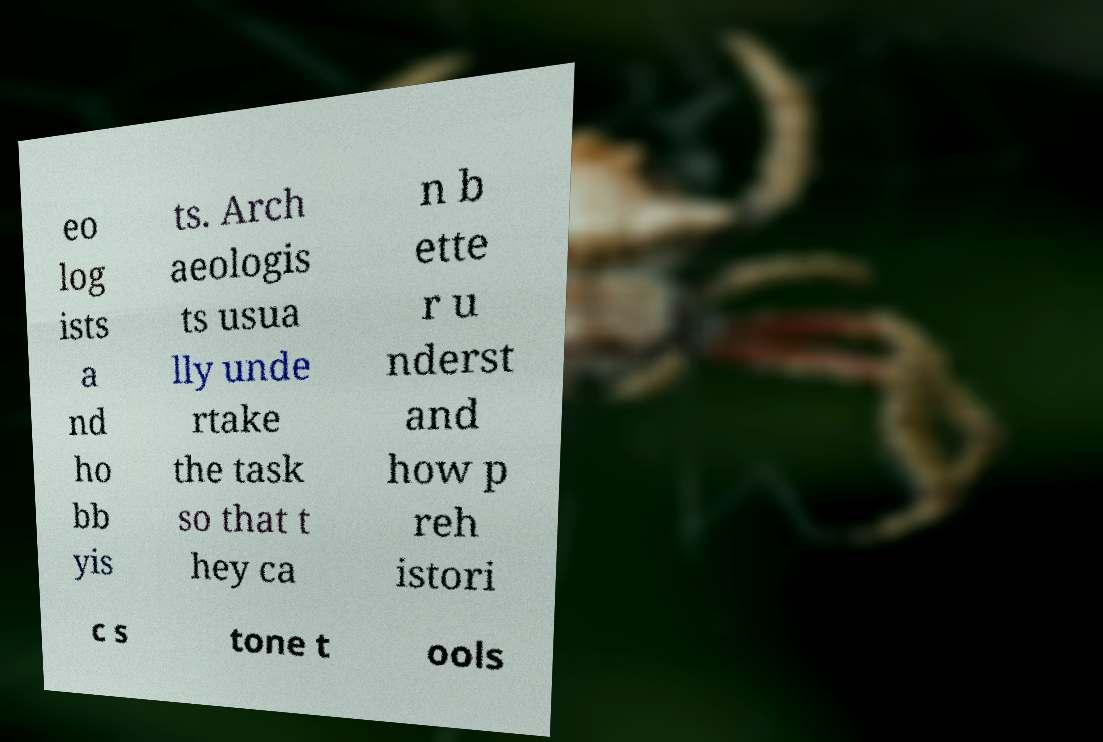Please read and relay the text visible in this image. What does it say? eo log ists a nd ho bb yis ts. Arch aeologis ts usua lly unde rtake the task so that t hey ca n b ette r u nderst and how p reh istori c s tone t ools 